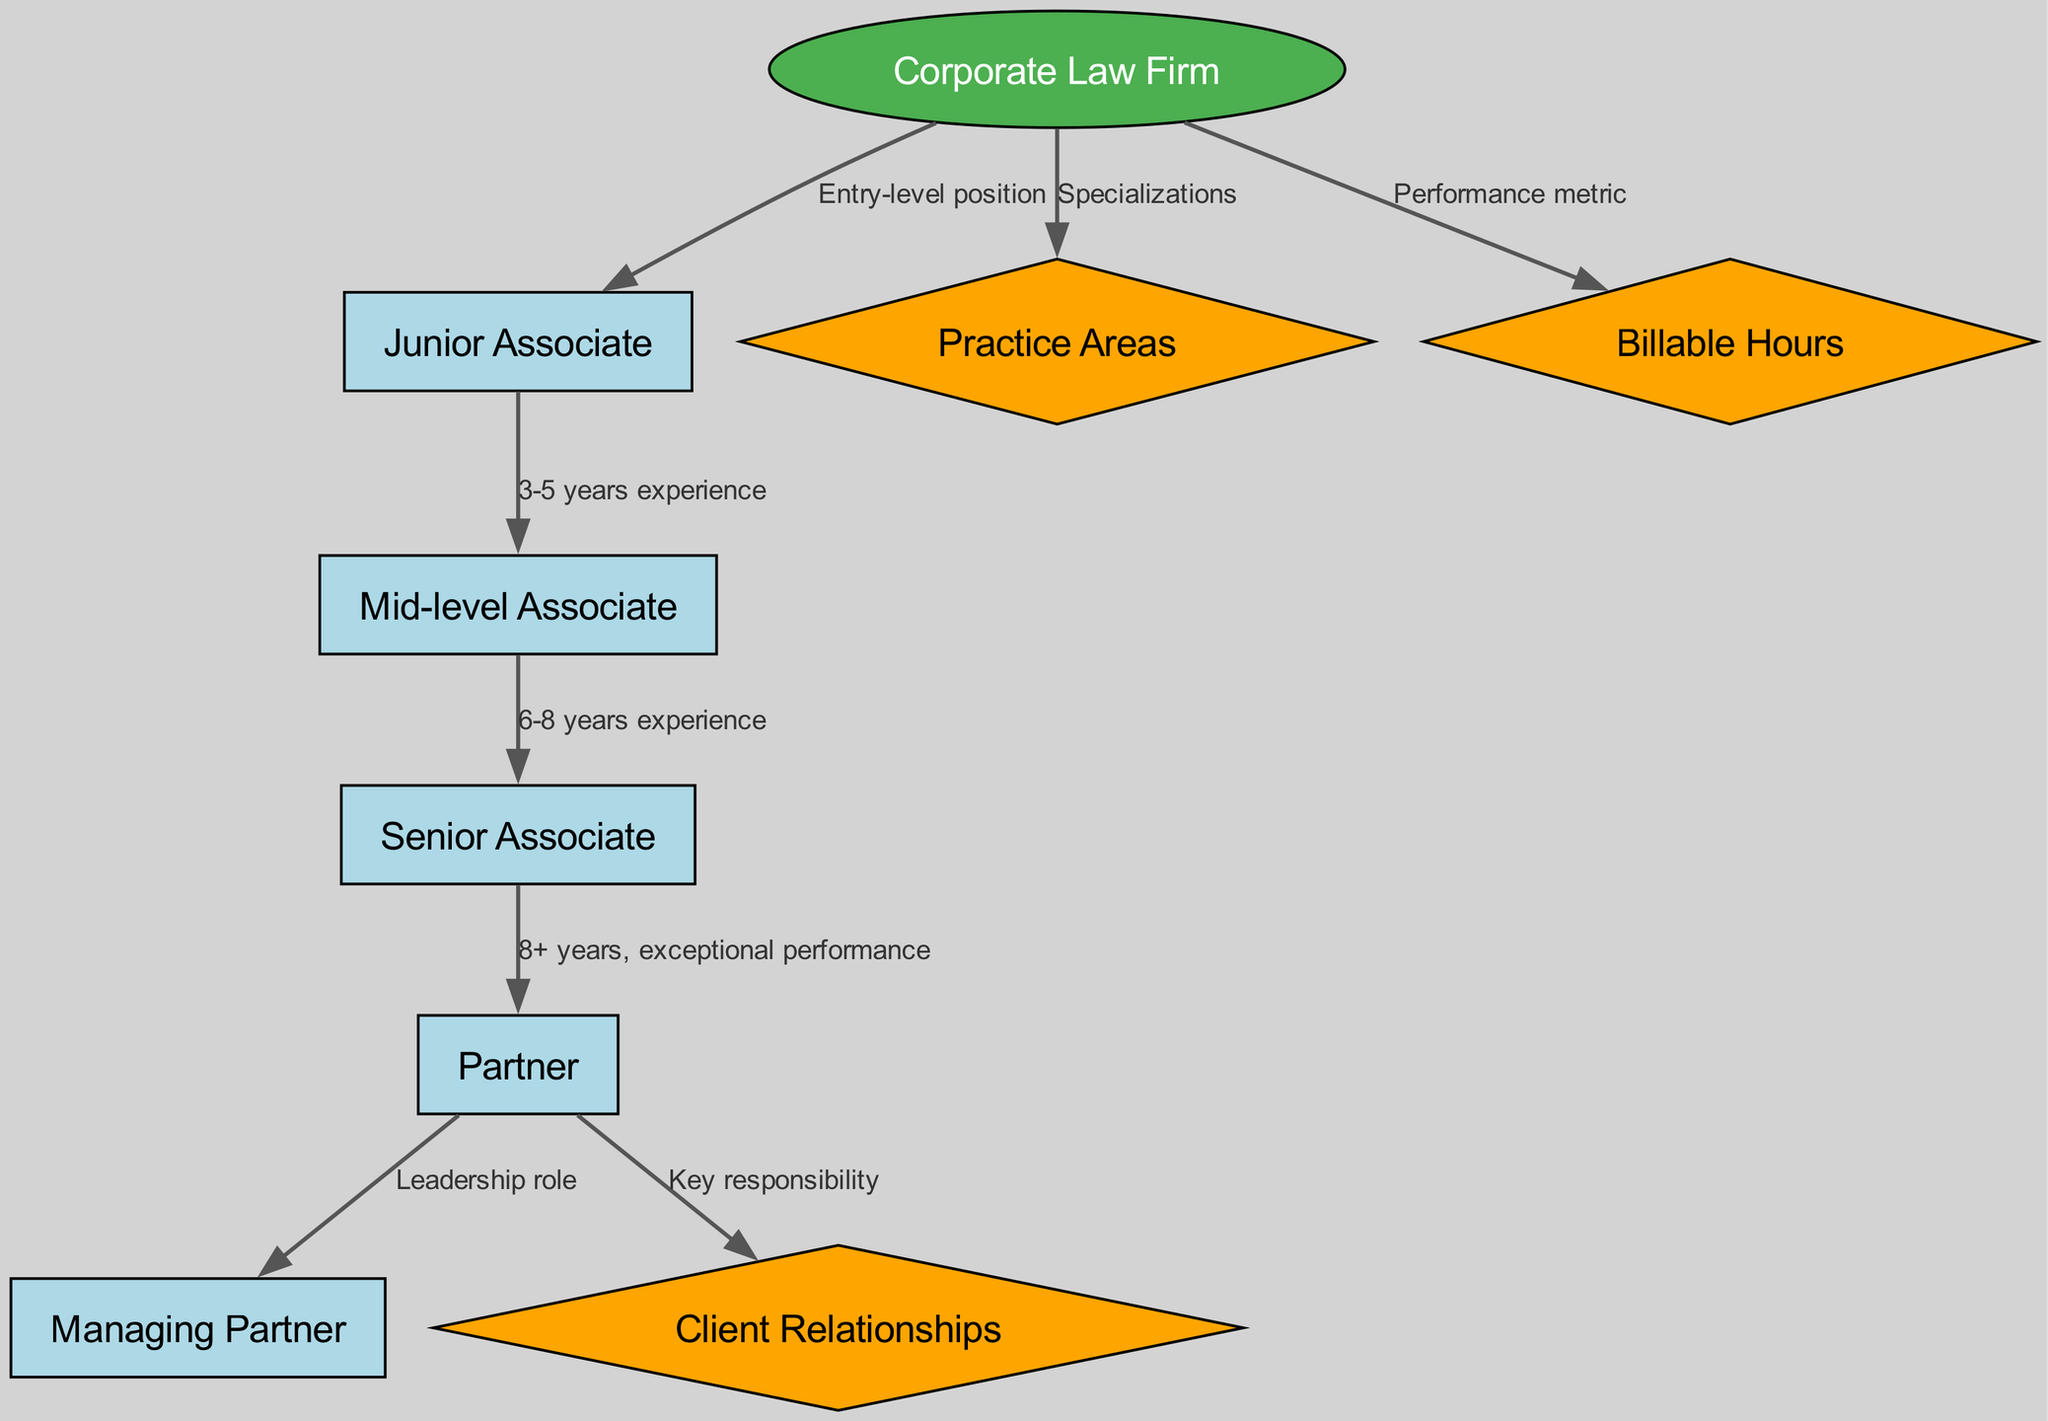What is the highest position in a corporate law firm? The diagram shows the hierarchy of a corporate law firm, with the top position labeled as "Managing Partner." Therefore, the highest position in the hierarchy is found at the top node.
Answer: Managing Partner How many years of experience does a Junior Associate typically have? According to the diagram, a Junior Associate is an entry-level position. There are no requirements listed, but it implies minimal to no experience, thus indicating the starting point of their career.
Answer: 0 What are the Billable Hours considered as in the firm? The diagram connects Billable Hours to the Corporate Law Firm through a labeled edge indicating it serves as a performance metric, showing its significance in assessing associate performance within the firm.
Answer: Performance metric What is the progression from Mid-level Associate to Senior Associate based on experience? The connection between Mid-level Associate and Senior Associate in the diagram specifies that this transition occurs after accumulating 6 to 8 years of experience. This edge explicitly indicates the requirement for advancement.
Answer: 6-8 years experience Which position is primarily responsible for Client Relationships? The edge from Partner to Client Relationships indicates that oversight and management in this area are mainly the responsibility of a Partner in the firm. Therefore, the diagram highlights this position's key responsibility.
Answer: Partner What is the relationship between Senior Associate and Partner in terms of performance? According to the diagram, the transition from Senior Associate to Partner is dependent on "8+ years, exceptional performance," which suggests that only those who demonstrate outstanding abilities are elevated to this level.
Answer: 8+ years, exceptional performance What is the total number of nodes present in the diagram? By counting the unique labels in the node section of the diagram, we find there are 9 nodes represented, each corresponding to different roles or elements within the corporate law firm hierarchy.
Answer: 9 How does one enter the Corporate Law Firm hierarchy? The diagram indicates that the entry point into the hierarchy is the Junior Associate position, which is clearly labeled as the entry-level position, marking the starting phase for law graduates.
Answer: Junior Associate What is the significance of a Managing Partner in relation to the Partner position? The connection between Partner and Managing Partner highlights a leadership role where the Managing Partner oversees and leads the firm, building upon the responsibilities assigned to Partners.
Answer: Leadership role 